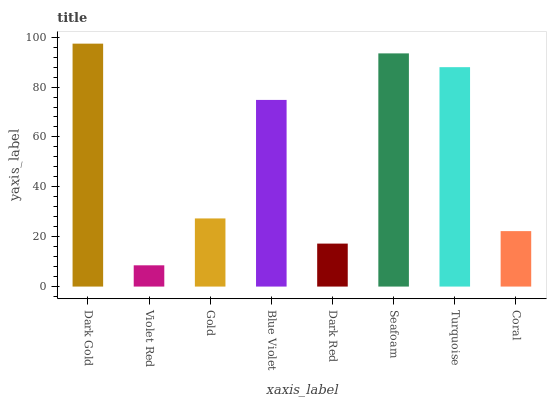Is Violet Red the minimum?
Answer yes or no. Yes. Is Dark Gold the maximum?
Answer yes or no. Yes. Is Gold the minimum?
Answer yes or no. No. Is Gold the maximum?
Answer yes or no. No. Is Gold greater than Violet Red?
Answer yes or no. Yes. Is Violet Red less than Gold?
Answer yes or no. Yes. Is Violet Red greater than Gold?
Answer yes or no. No. Is Gold less than Violet Red?
Answer yes or no. No. Is Blue Violet the high median?
Answer yes or no. Yes. Is Gold the low median?
Answer yes or no. Yes. Is Gold the high median?
Answer yes or no. No. Is Turquoise the low median?
Answer yes or no. No. 